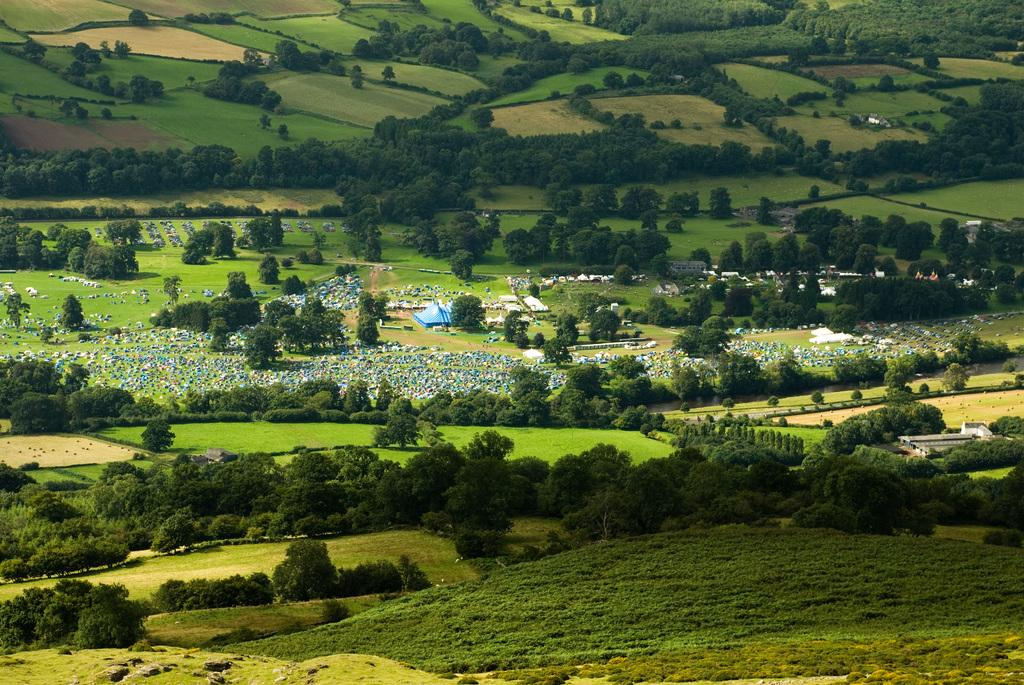What type of vegetation is visible in the image? There are trees in the image. What type of ground cover is present in the image? There is grass in the image. What type of structures can be seen in the image? There are houses in the image. What type of geographical feature is visible in the image? There are hills in the image. What type of songs can be heard being sung by the trees in the image? Trees do not sing songs, so there are no songs being sung by the trees in the image. What type of battle is taking place between the hills and the houses in the image? There is no battle taking place between the hills and the houses in the image. 